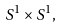<formula> <loc_0><loc_0><loc_500><loc_500>S ^ { 1 } \times S ^ { 1 } ,</formula> 